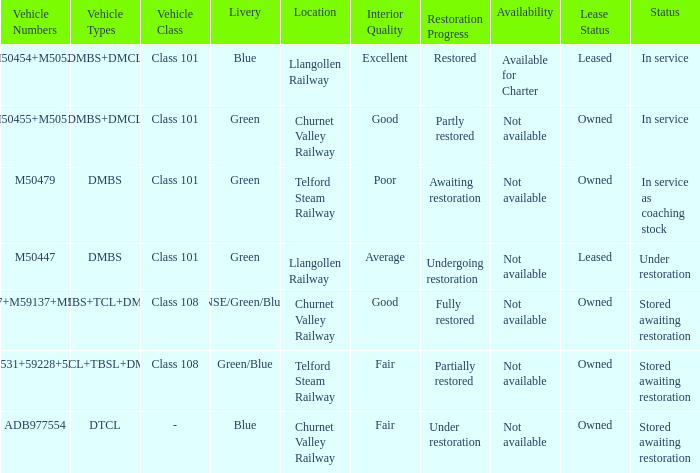What status is the vehicle types of dmbs+tcl+dmcl? Stored awaiting restoration. 